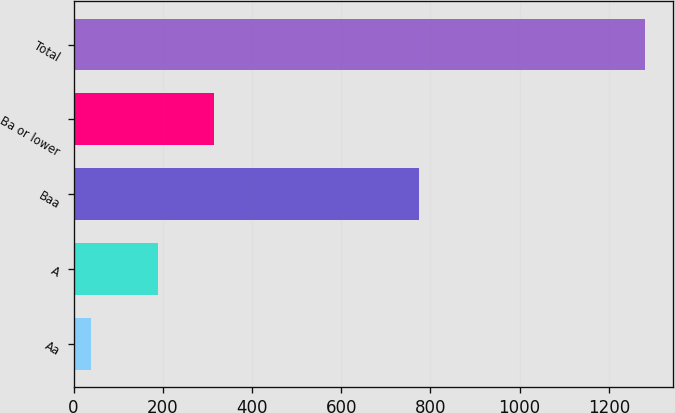Convert chart to OTSL. <chart><loc_0><loc_0><loc_500><loc_500><bar_chart><fcel>Aa<fcel>A<fcel>Baa<fcel>Ba or lower<fcel>Total<nl><fcel>38<fcel>190<fcel>774<fcel>314.3<fcel>1281<nl></chart> 